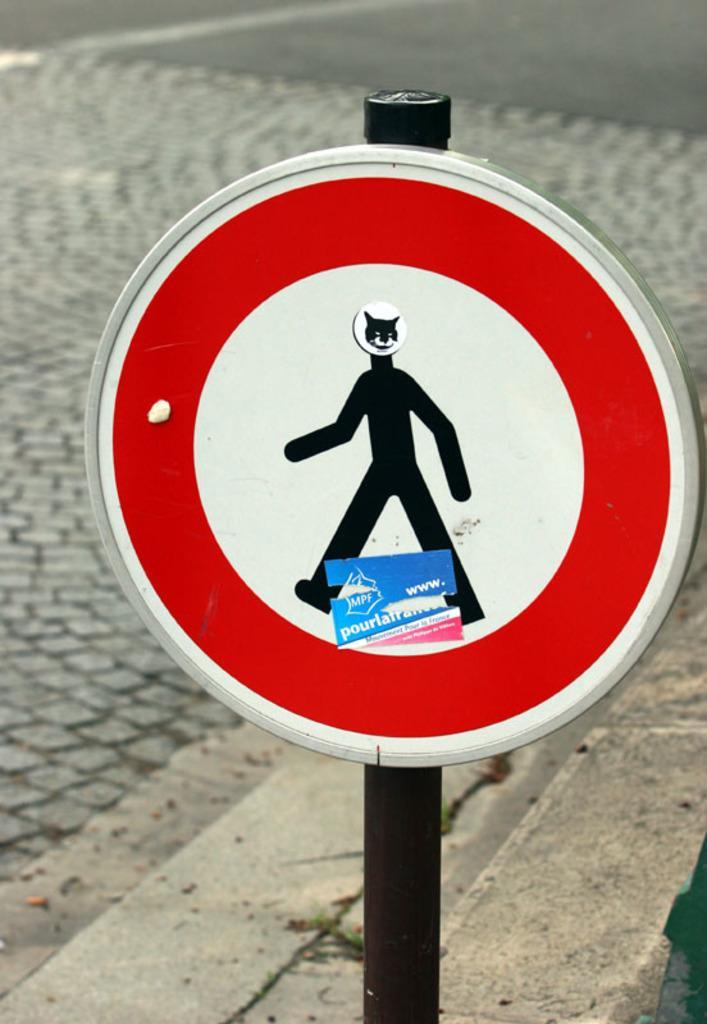Can you describe this image briefly? In this image in the foreground I can see a signal board in the background there is the road. 